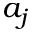Convert formula to latex. <formula><loc_0><loc_0><loc_500><loc_500>a _ { j }</formula> 